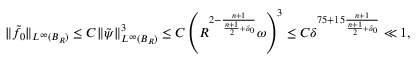<formula> <loc_0><loc_0><loc_500><loc_500>\begin{array} { r } { \| \tilde { f } _ { 0 } \| _ { L ^ { \infty } ( B _ { R } ) } \leq C \| \tilde { \psi } \| _ { L ^ { \infty } ( B _ { R } ) } ^ { 3 } \leq C \left ( R ^ { 2 - \frac { n + 1 } { \frac { n + 1 } { 2 } + \delta _ { 0 } } } \omega \right ) ^ { 3 } \leq C \delta ^ { 7 5 + 1 5 \frac { n + 1 } { \frac { n + 1 } { 2 } + \delta _ { 0 } } } \ll 1 , } \end{array}</formula> 